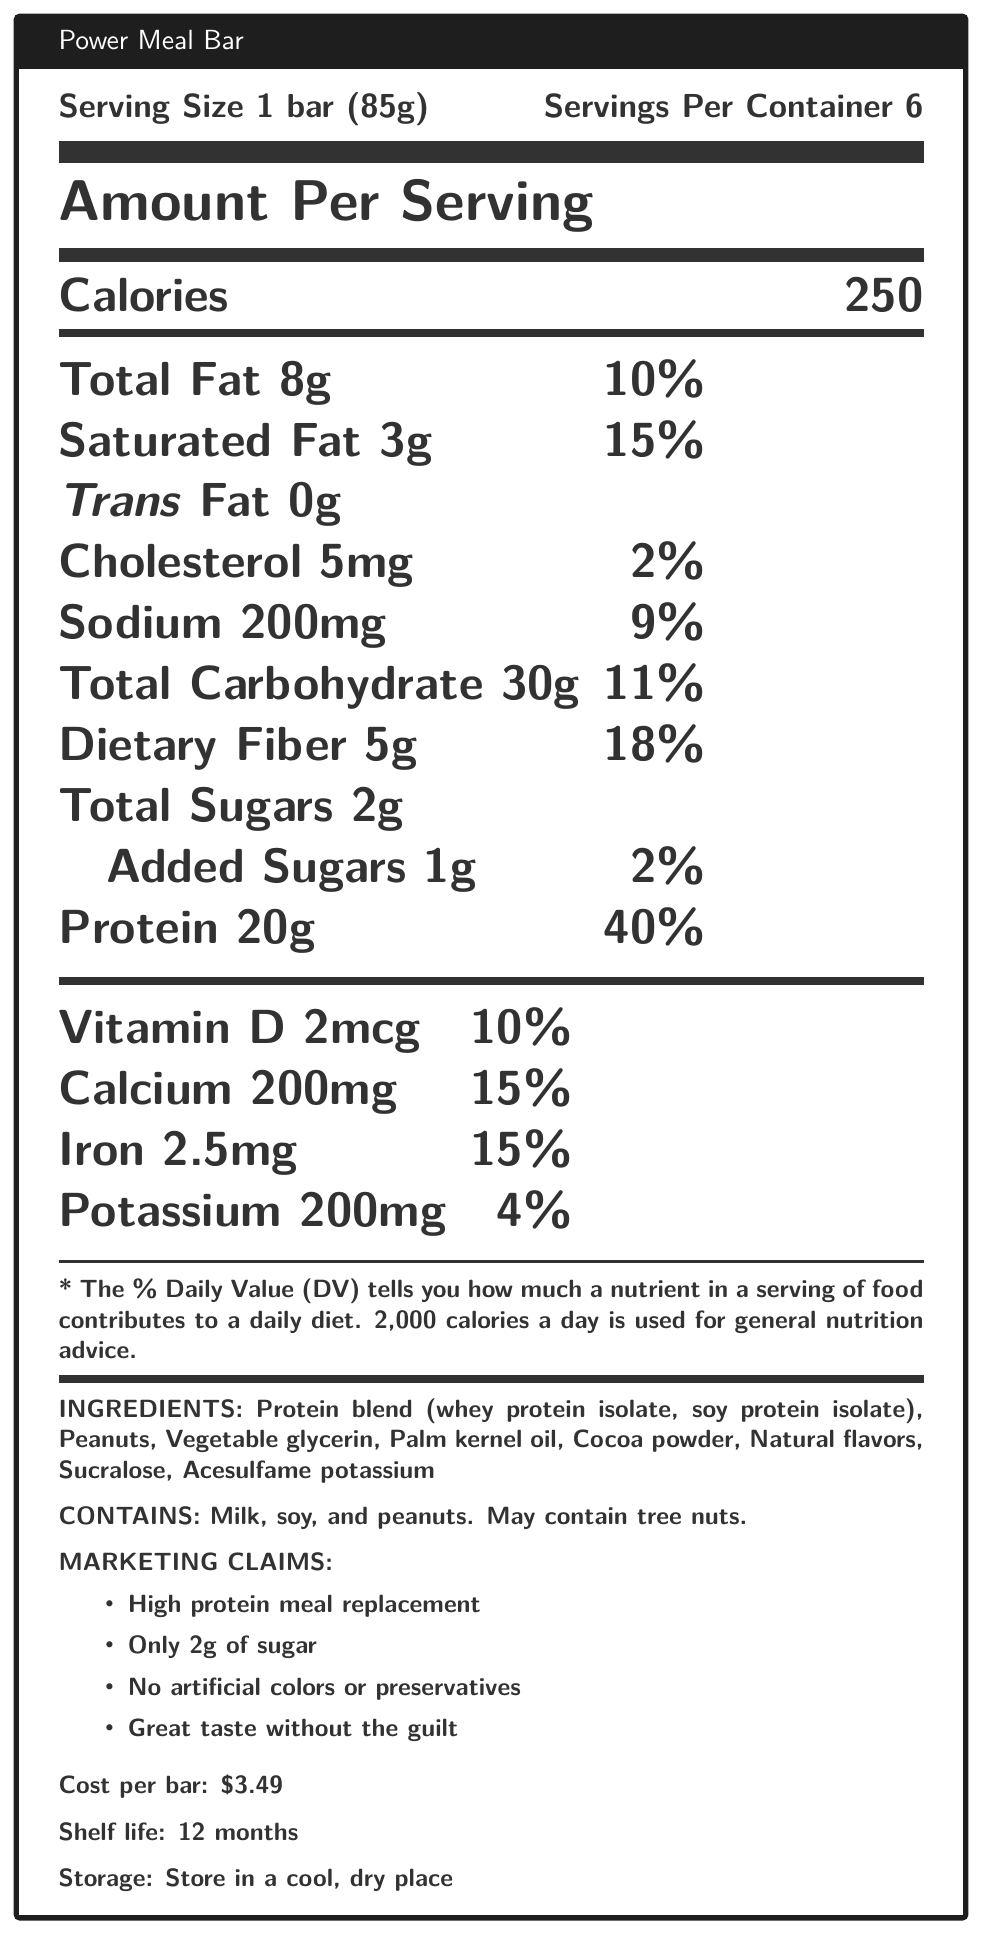what is the serving size of the Power Meal Bar? The serving size is specified as "1 bar (85g)" in the nutrition facts section.
Answer: 1 bar (85g) how many calories are in one serving of the Power Meal Bar? The nutrition label states that the bar contains 250 calories per serving.
Answer: 250 what percentage of the daily value for protein does one Power Meal Bar provide? According to the nutrition facts, one bar provides 20g of protein, which is 40% of the daily value.
Answer: 40% what is the total amount of carbohydrates in one bar? The total carbohydrate content per serving is listed as 30g.
Answer: 30g what is the cost per bar of the Power Meal Bar? The document mentions that each bar costs $3.49.
Answer: $3.49 how much Dietary Fiber does one serving contain? The nutrition facts show that there are 5g of dietary fiber per serving.
Answer: 5g how long is the shelf life of the Power Meal Bar? The document states that the shelf life of the bar is 12 months.
Answer: 12 months how much iron is in one serving of the Power Meal Bar? The iron content per serving is listed as 2.5mg.
Answer: 2.5mg which of the following artificial sweeteners are included in the ingredients? A. Aspartame B. Saccharin C. Sucralose D. Stevia The ingredients list includes Sucralose as one of the artificial sweeteners.
Answer: C. Sucralose how much Saturated Fat does one Power Meal Bar contain? A. 5g B. 8g C. 3g D. 0g The amount of Saturated Fat per serving is specified as 3g.
Answer: C. 3g is this product high in protein? The product contains 20g of protein per bar, which is 40% of the daily value, making it high in protein.
Answer: Yes does the Power Meal Bar contain any cholesterol? The nutrition facts label indicates that there is 5mg of cholesterol per serving.
Answer: Yes does the Power Meal Bar contain artificial colors or preservatives? One of the marketing claims specifically states that the product contains no artificial colors or preservatives.
Answer: No summarize the main idea of the document. This summary captures the key points about nutrition content, cost, shelf life, and marketing claims, providing a comprehensive overview of the Power Meal Bar based on the document.
Answer: The Power Meal Bar is a meal replacement protein bar with 20g of protein per serving and minimal sugars. It is low in artificial ingredients, costs $3.49 per bar, and has a shelf life of 12 months. The nutrition label provides detailed information about the caloric content, macro- and micronutrients, and ingredients, while marketing claims emphasize its health benefits and lack of artificial additives. what is the recommended storage condition for the Power Meal Bar according to the document? The document states that the recommended storage condition for the bar is to keep it in a cool, dry place.
Answer: Store in a cool, dry place how many bars are contained in one package of Power Meal Bars? The document indicates that there are 6 servings per container, implying there are 6 bars in one package.
Answer: 6 which nutrient is present in the greatest amount in the Power Meal Bar per serving? Protein is present in the greatest amount per serving with 20g, as highlighted in the nutrition facts.
Answer: Protein (20g) what are the allergenic ingredients in the Power Meal Bar? The document lists milk, soy, and peanuts as allergens and also mentions that the product may contain tree nuts.
Answer: Milk, soy, and peanuts is the Power Meal Bar an effective meal replacement for someone on a strictly low-carb diet? While the Power Meal Bar does contain 30g of carbohydrates per serving, including 5g of dietary fiber, the information provided is not sufficient to conclusively determine its suitability for a strictly low-carb diet without more context on the individual's specific dietary requirements.
Answer: Not enough information 